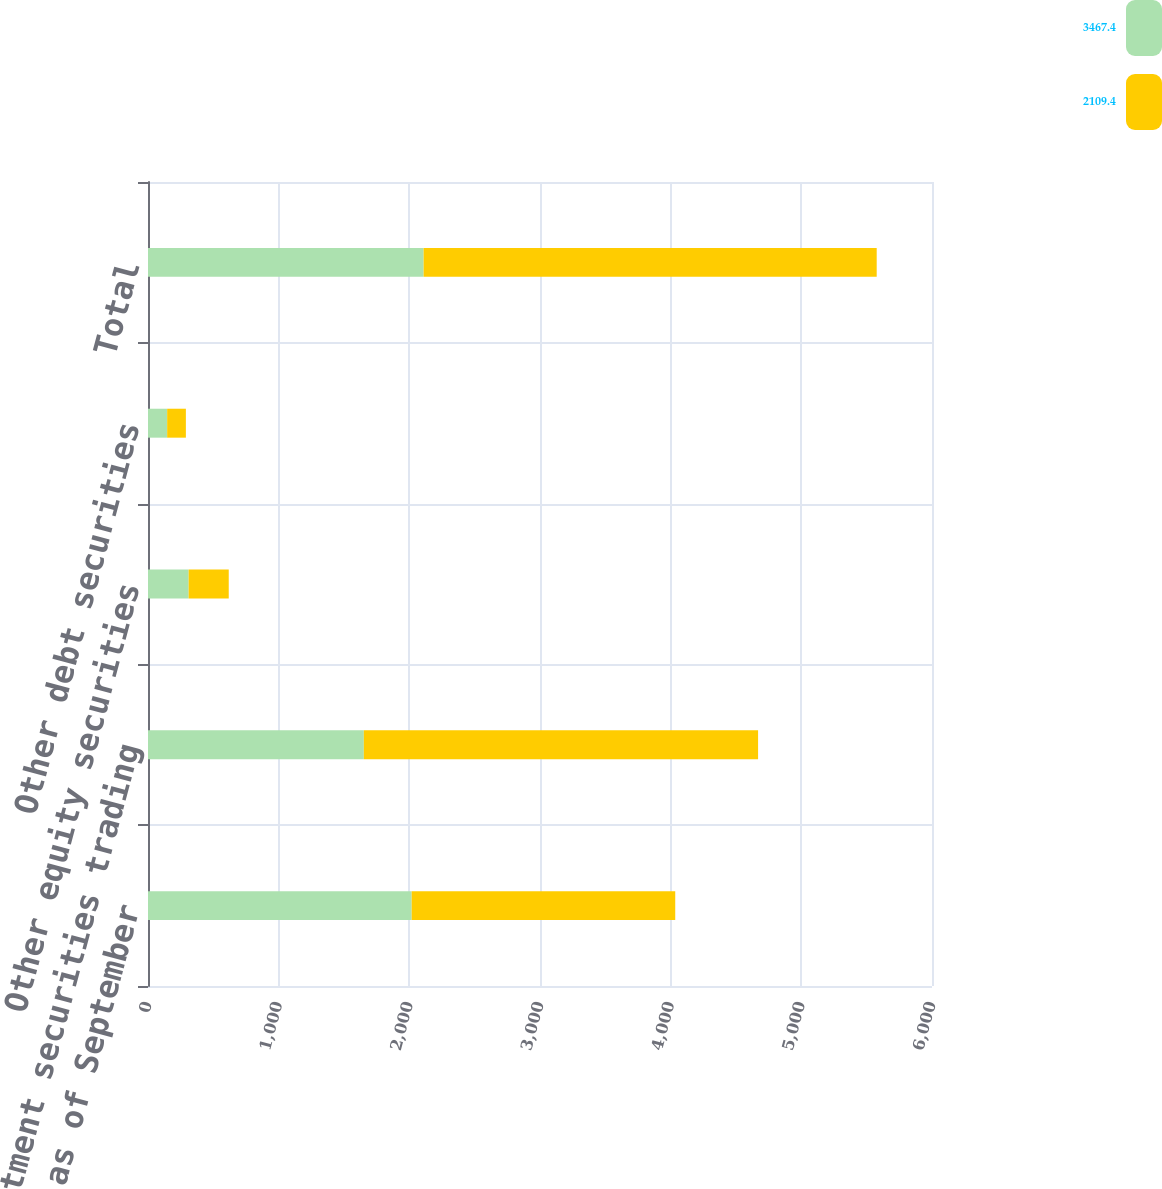Convert chart. <chart><loc_0><loc_0><loc_500><loc_500><stacked_bar_chart><ecel><fcel>(in millions) as of September<fcel>Investment securities trading<fcel>Other equity securities<fcel>Other debt securities<fcel>Total<nl><fcel>3467.4<fcel>2018<fcel>1651.8<fcel>311<fcel>146.6<fcel>2109.4<nl><fcel>2109.4<fcel>2017<fcel>3017.2<fcel>306.9<fcel>143.3<fcel>3467.4<nl></chart> 